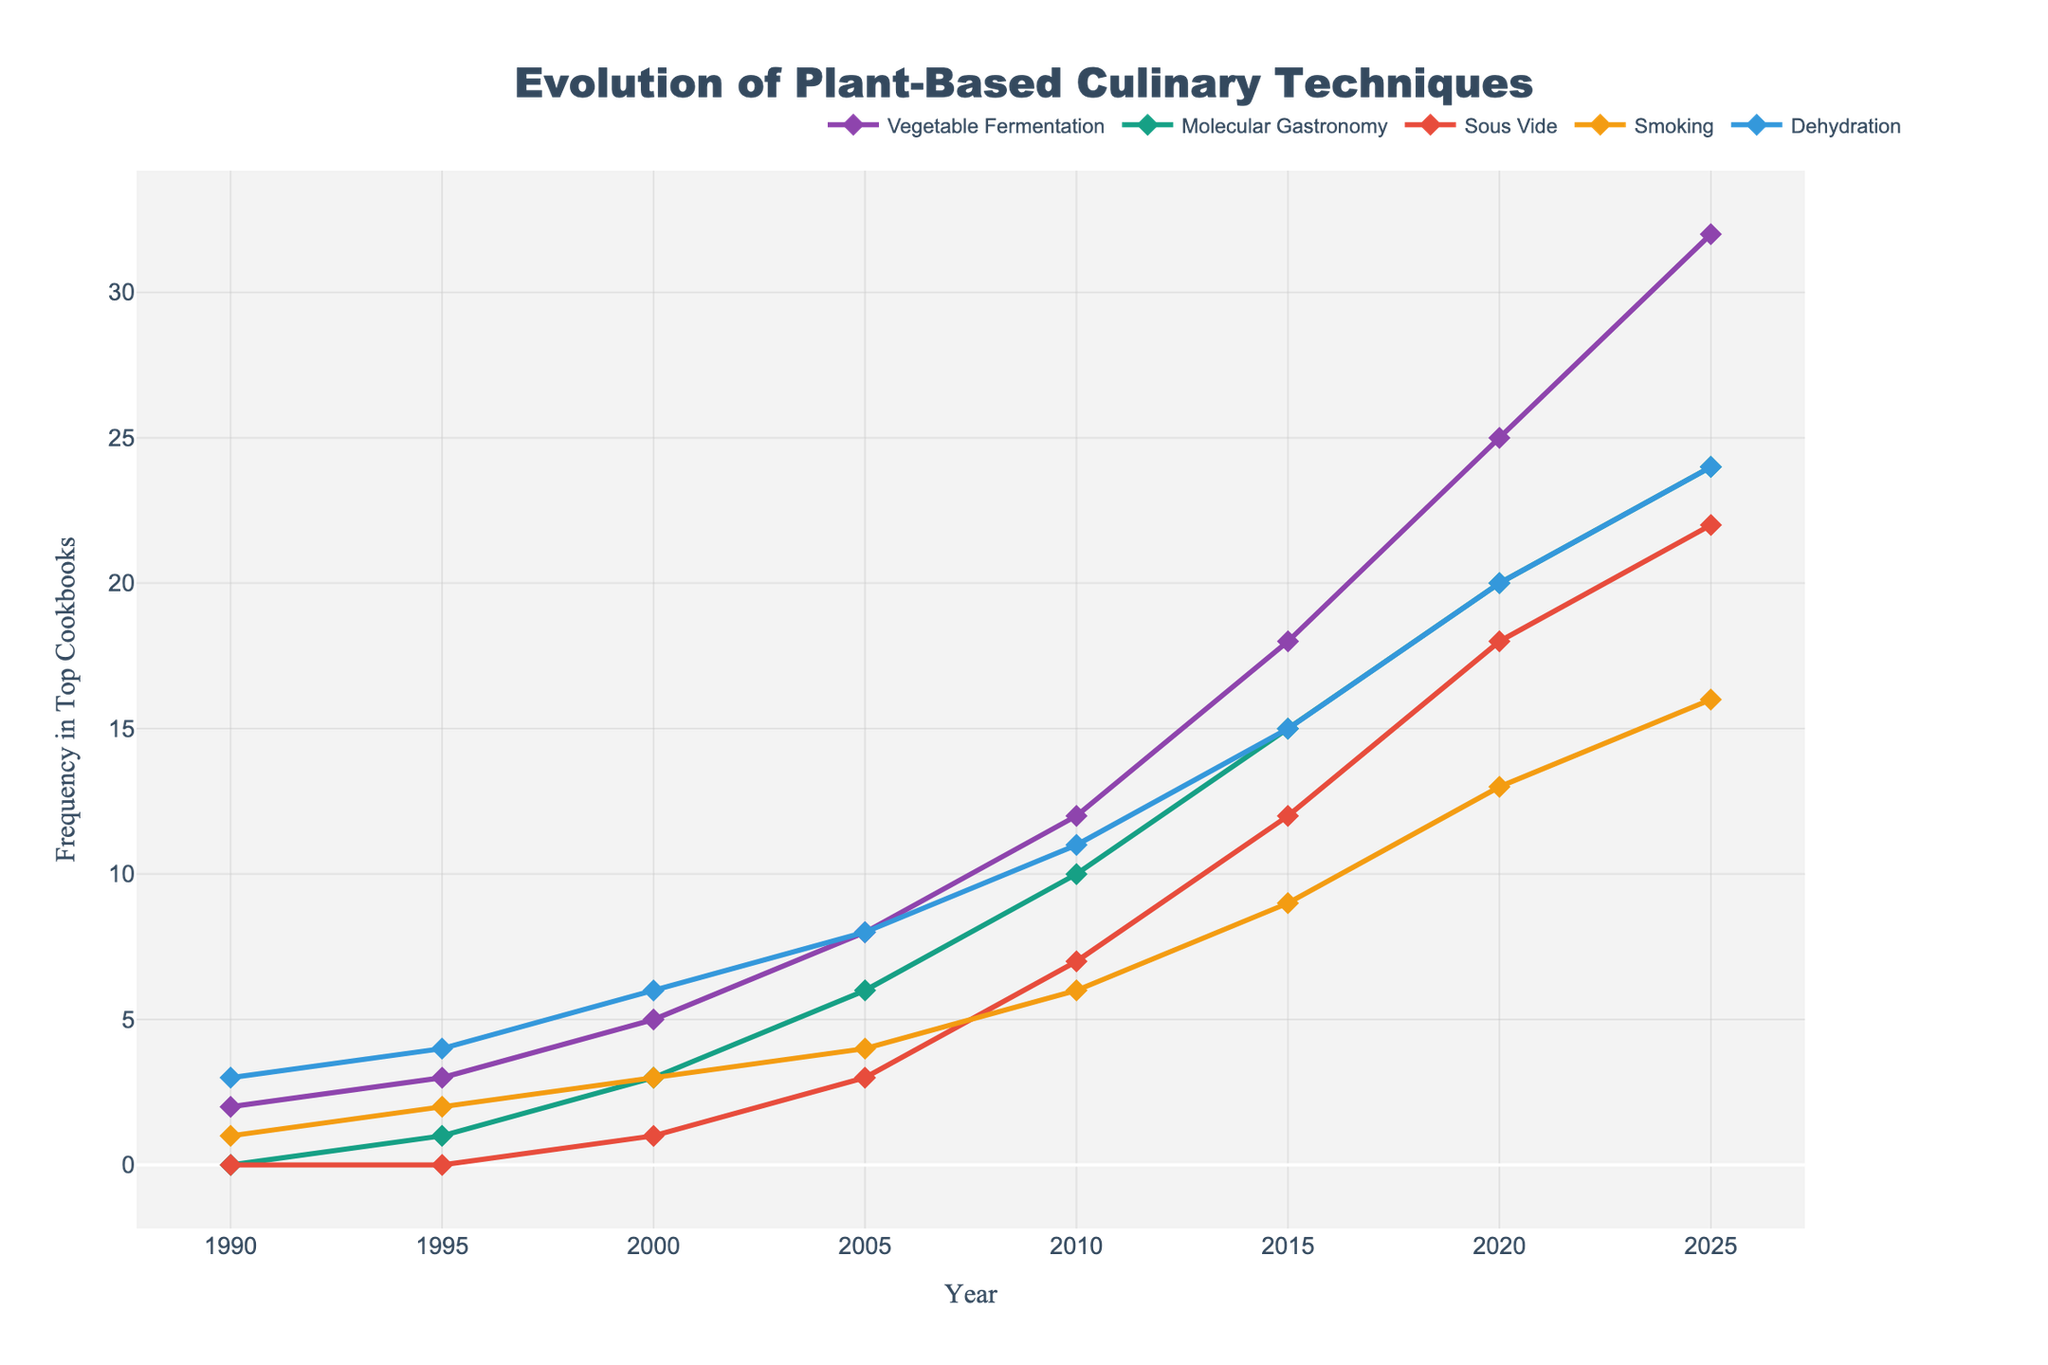What is the frequency of Vegetable Fermentation in 2020 compared to 1990? To find the difference in the frequency of Vegetable Fermentation between 2020 and 1990, subtract the 1990 value from the 2020 value. In 2020, the frequency is 25, and in 1990, it is 2. So, 25 - 2 = 23.
Answer: 23 Which technique shows the highest frequency increase between 2005 and 2015? To find the technique with the highest frequency increase, look at the differences in values between 2005 and 2015 for each technique. The increases are: Vegetable Fermentation (18 - 8 = 10), Molecular Gastronomy (15 - 6 = 9), Sous Vide (12 - 3 = 9), Smoking (9 - 4 = 5), and Dehydration (15 - 8 = 7). Vegetable Fermentation has the highest increase.
Answer: Vegetable Fermentation What was the total frequency of all techniques combined in 2010? To find the total frequency, add up all the technique frequencies in 2010. These values are Vegetable Fermentation (12), Molecular Gastronomy (10), Sous Vide (7), Smoking (6), and Dehydration (11). So, the total is 12 + 10 + 7 + 6 + 11 = 46.
Answer: 46 Which technique had the lowest frequency in 2000? Look at the frequencies for each technique in 2000: Vegetable Fermentation (5), Molecular Gastronomy (3), Sous Vide (1), Smoking (3), and Dehydration (6). Sous Vide has the lowest frequency.
Answer: Sous Vide What is the average frequency of Dehydration over the entire period? To find the average frequency, sum the values for Dehydration across all years and divide by the number of years. The values are 3, 4, 6, 8, 11, 15, 20, and 24. Summing these, we get 91. There are 8 years, so the average is 91 / 8 = 11.375.
Answer: 11.375 How did the frequency of Sous Vide change from 2015 to 2025? To determine the change in frequency, subtract the 2015 value from the 2025 value for Sous Vide. In 2025, the frequency is 22, and in 2015, it is 12. So, 22 - 12 = 10.
Answer: 10 In what year did Molecular Gastronomy first appear with a frequency greater than 10? Examine the data for Molecular Gastronomy over the years. The first occurrence where the frequency exceeds 10 is in 2015 when the frequency is 15.
Answer: 2015 Which culinary technique had the most consistent increase in frequency over the period? Consistency can be measured by stable incremental increases over the years. By examining each technique, Vegetable Fermentation shows the most consistent increase from 1990 (2) to 2025 (32).
Answer: Vegetable Fermentation 